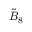<formula> <loc_0><loc_0><loc_500><loc_500>{ \tilde { B } } _ { 8 }</formula> 